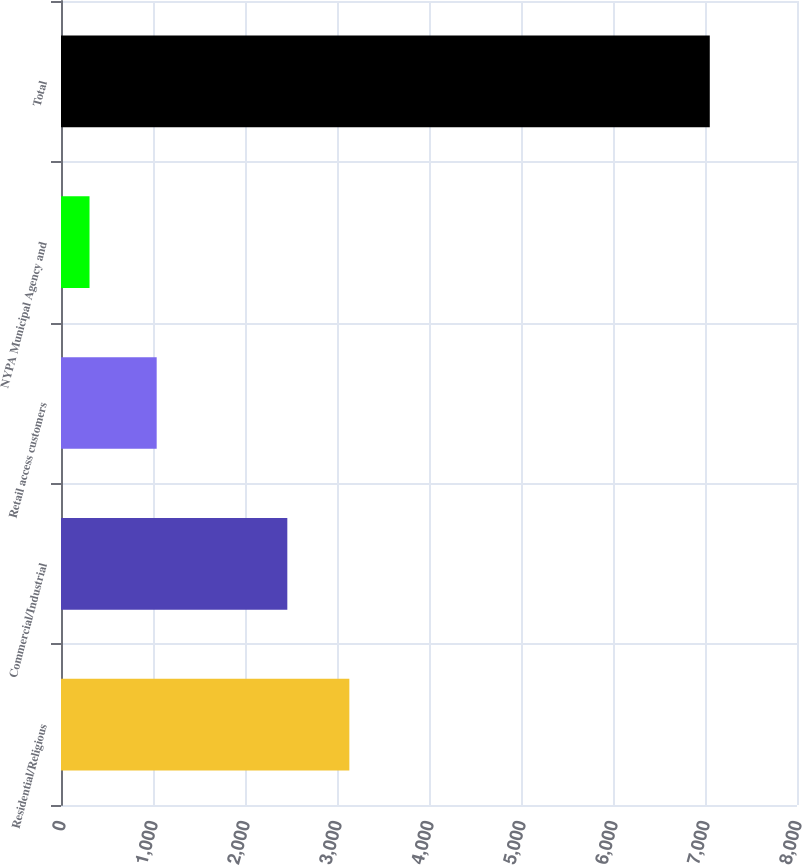Convert chart. <chart><loc_0><loc_0><loc_500><loc_500><bar_chart><fcel>Residential/Religious<fcel>Commercial/Industrial<fcel>Retail access customers<fcel>NYPA Municipal Agency and<fcel>Total<nl><fcel>3134.2<fcel>2460<fcel>1040<fcel>310<fcel>7052<nl></chart> 